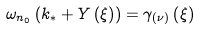Convert formula to latex. <formula><loc_0><loc_0><loc_500><loc_500>\omega _ { n _ { 0 } } \left ( k _ { \ast } + Y \left ( \xi \right ) \right ) = \gamma _ { \left ( \nu \right ) } \left ( \xi \right )</formula> 